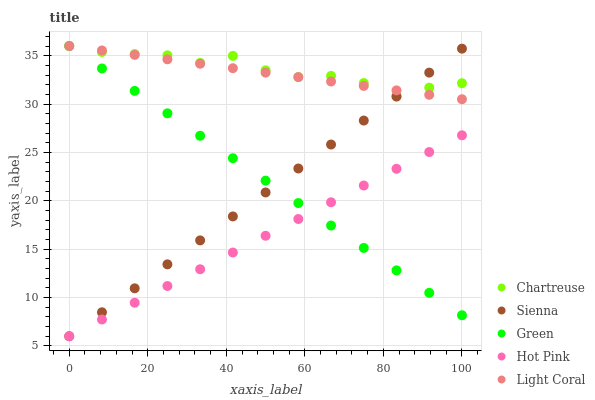Does Hot Pink have the minimum area under the curve?
Answer yes or no. Yes. Does Chartreuse have the maximum area under the curve?
Answer yes or no. Yes. Does Light Coral have the minimum area under the curve?
Answer yes or no. No. Does Light Coral have the maximum area under the curve?
Answer yes or no. No. Is Green the smoothest?
Answer yes or no. Yes. Is Chartreuse the roughest?
Answer yes or no. Yes. Is Light Coral the smoothest?
Answer yes or no. No. Is Light Coral the roughest?
Answer yes or no. No. Does Sienna have the lowest value?
Answer yes or no. Yes. Does Light Coral have the lowest value?
Answer yes or no. No. Does Green have the highest value?
Answer yes or no. Yes. Does Hot Pink have the highest value?
Answer yes or no. No. Is Hot Pink less than Light Coral?
Answer yes or no. Yes. Is Light Coral greater than Hot Pink?
Answer yes or no. Yes. Does Hot Pink intersect Green?
Answer yes or no. Yes. Is Hot Pink less than Green?
Answer yes or no. No. Is Hot Pink greater than Green?
Answer yes or no. No. Does Hot Pink intersect Light Coral?
Answer yes or no. No. 